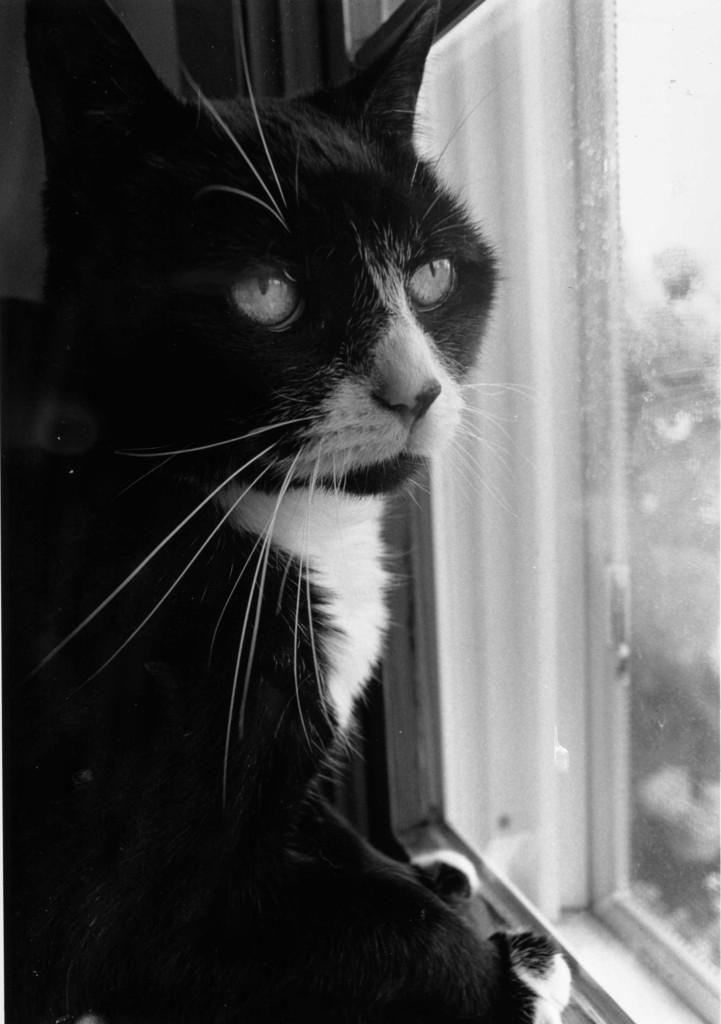What is the main subject of the image? There is a cat in the center of the image. Can you describe the appearance of the cat? The cat is black and white in color. What can be seen in the background of the image? There is a wall and a window in the background of the image. What is the rate at which the cat is attempting to swing on the window in the image? There is no indication in the image that the cat is attempting to swing on the window, and therefore no rate can be determined. 